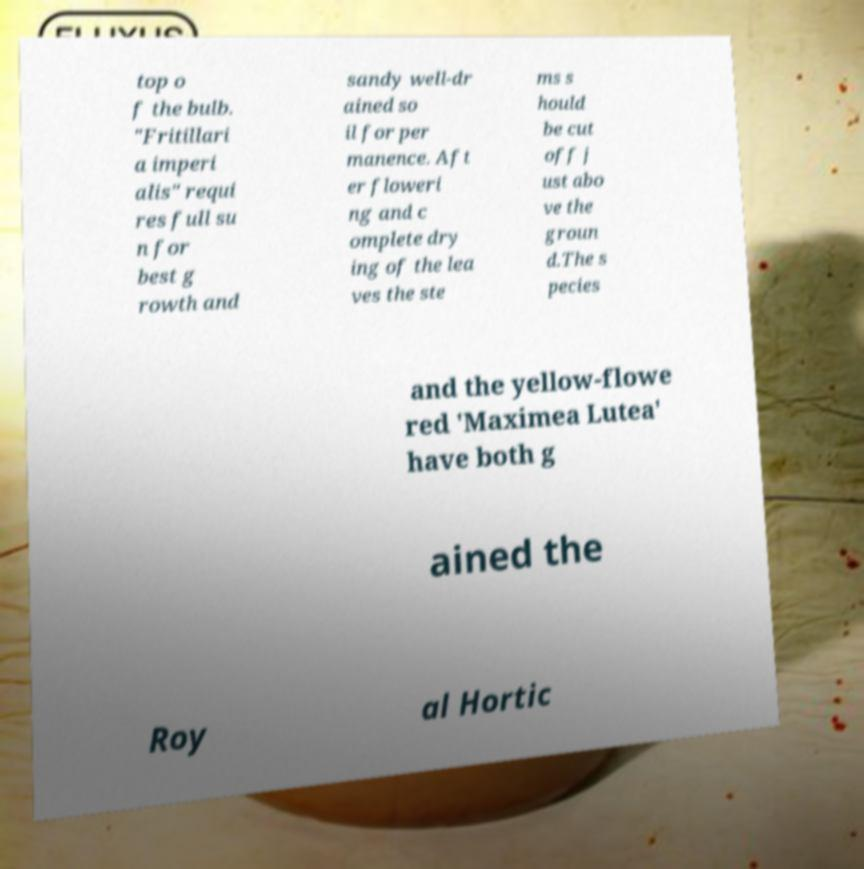I need the written content from this picture converted into text. Can you do that? top o f the bulb. "Fritillari a imperi alis" requi res full su n for best g rowth and sandy well-dr ained so il for per manence. Aft er floweri ng and c omplete dry ing of the lea ves the ste ms s hould be cut off j ust abo ve the groun d.The s pecies and the yellow-flowe red 'Maximea Lutea' have both g ained the Roy al Hortic 